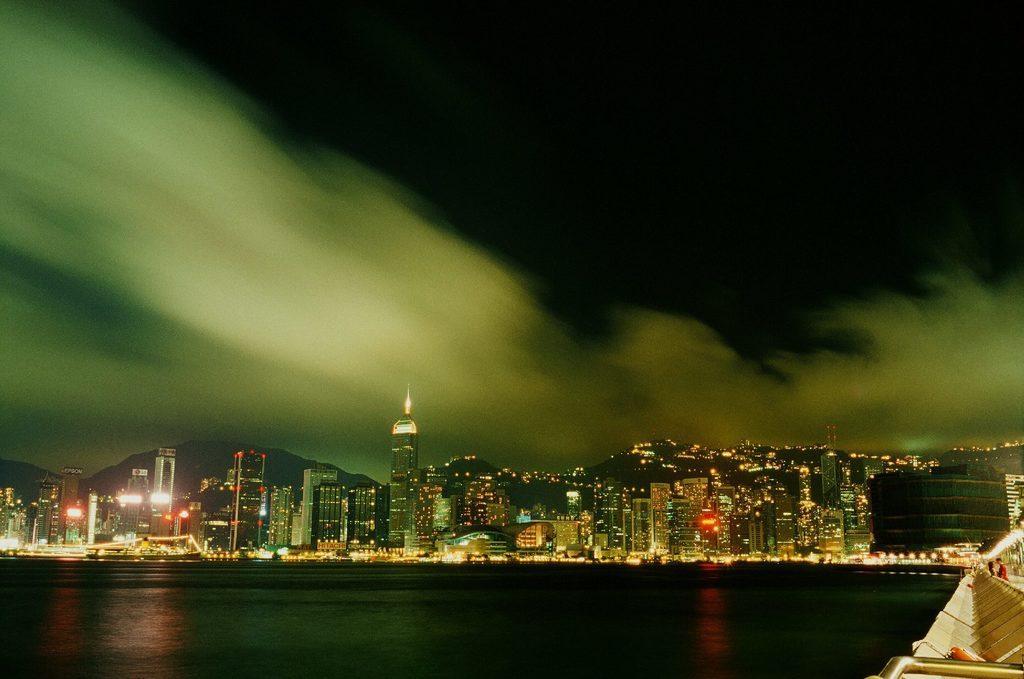Can you describe this image briefly? In this picture I can see the water in front and in the background I can see number of buildings and I can also see the lights. On the top of this picture I can see the sky. 